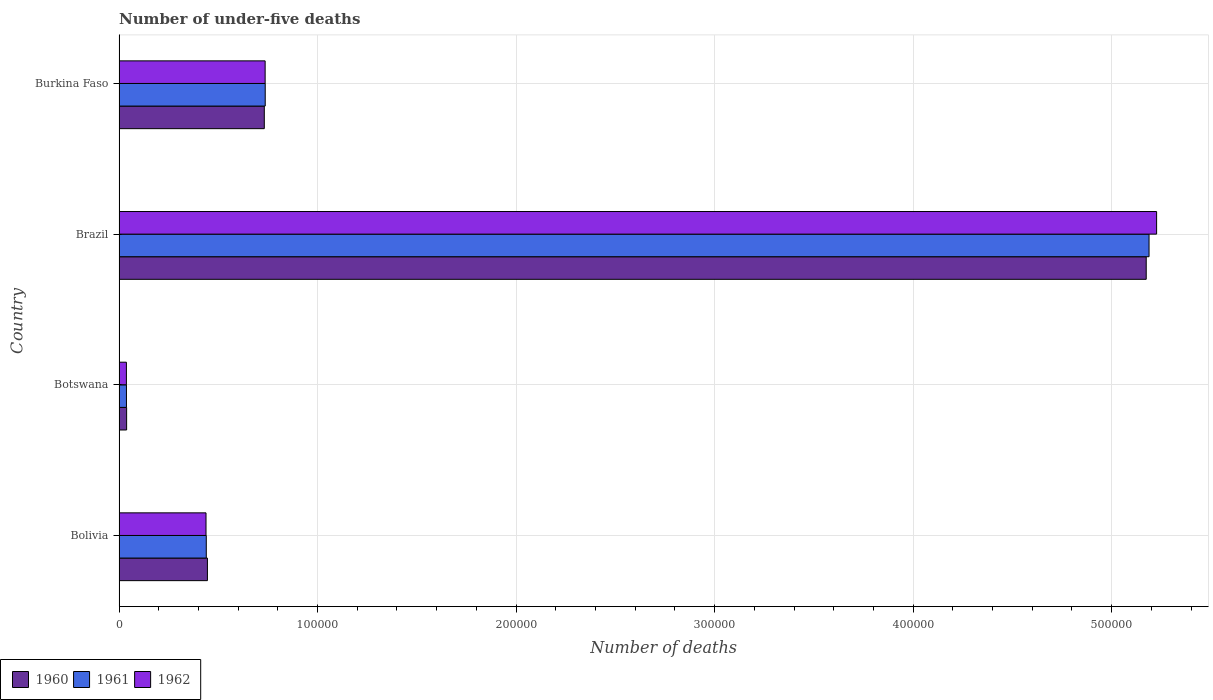How many different coloured bars are there?
Keep it short and to the point. 3. How many groups of bars are there?
Give a very brief answer. 4. How many bars are there on the 3rd tick from the bottom?
Provide a short and direct response. 3. What is the label of the 3rd group of bars from the top?
Provide a short and direct response. Botswana. In how many cases, is the number of bars for a given country not equal to the number of legend labels?
Provide a short and direct response. 0. What is the number of under-five deaths in 1961 in Botswana?
Your answer should be compact. 3727. Across all countries, what is the maximum number of under-five deaths in 1962?
Make the answer very short. 5.23e+05. Across all countries, what is the minimum number of under-five deaths in 1961?
Make the answer very short. 3727. In which country was the number of under-five deaths in 1961 maximum?
Ensure brevity in your answer.  Brazil. In which country was the number of under-five deaths in 1962 minimum?
Make the answer very short. Botswana. What is the total number of under-five deaths in 1960 in the graph?
Provide a short and direct response. 6.39e+05. What is the difference between the number of under-five deaths in 1960 in Bolivia and that in Burkina Faso?
Offer a very short reply. -2.87e+04. What is the difference between the number of under-five deaths in 1962 in Burkina Faso and the number of under-five deaths in 1961 in Botswana?
Offer a terse response. 6.99e+04. What is the average number of under-five deaths in 1960 per country?
Make the answer very short. 1.60e+05. What is the difference between the number of under-five deaths in 1961 and number of under-five deaths in 1962 in Burkina Faso?
Offer a very short reply. 42. What is the ratio of the number of under-five deaths in 1960 in Brazil to that in Burkina Faso?
Give a very brief answer. 7.07. What is the difference between the highest and the second highest number of under-five deaths in 1960?
Your answer should be very brief. 4.44e+05. What is the difference between the highest and the lowest number of under-five deaths in 1961?
Your answer should be compact. 5.15e+05. How many countries are there in the graph?
Your response must be concise. 4. Does the graph contain any zero values?
Your response must be concise. No. Where does the legend appear in the graph?
Keep it short and to the point. Bottom left. What is the title of the graph?
Keep it short and to the point. Number of under-five deaths. What is the label or title of the X-axis?
Provide a short and direct response. Number of deaths. What is the label or title of the Y-axis?
Your response must be concise. Country. What is the Number of deaths of 1960 in Bolivia?
Your answer should be very brief. 4.45e+04. What is the Number of deaths of 1961 in Bolivia?
Offer a terse response. 4.39e+04. What is the Number of deaths in 1962 in Bolivia?
Provide a short and direct response. 4.38e+04. What is the Number of deaths of 1960 in Botswana?
Your answer should be very brief. 3811. What is the Number of deaths of 1961 in Botswana?
Keep it short and to the point. 3727. What is the Number of deaths of 1962 in Botswana?
Ensure brevity in your answer.  3708. What is the Number of deaths in 1960 in Brazil?
Your answer should be very brief. 5.17e+05. What is the Number of deaths of 1961 in Brazil?
Offer a terse response. 5.19e+05. What is the Number of deaths of 1962 in Brazil?
Keep it short and to the point. 5.23e+05. What is the Number of deaths in 1960 in Burkina Faso?
Make the answer very short. 7.32e+04. What is the Number of deaths of 1961 in Burkina Faso?
Your answer should be compact. 7.36e+04. What is the Number of deaths of 1962 in Burkina Faso?
Keep it short and to the point. 7.36e+04. Across all countries, what is the maximum Number of deaths in 1960?
Your response must be concise. 5.17e+05. Across all countries, what is the maximum Number of deaths of 1961?
Your answer should be very brief. 5.19e+05. Across all countries, what is the maximum Number of deaths of 1962?
Provide a short and direct response. 5.23e+05. Across all countries, what is the minimum Number of deaths of 1960?
Your response must be concise. 3811. Across all countries, what is the minimum Number of deaths of 1961?
Give a very brief answer. 3727. Across all countries, what is the minimum Number of deaths in 1962?
Keep it short and to the point. 3708. What is the total Number of deaths in 1960 in the graph?
Provide a short and direct response. 6.39e+05. What is the total Number of deaths of 1961 in the graph?
Offer a terse response. 6.40e+05. What is the total Number of deaths in 1962 in the graph?
Your response must be concise. 6.44e+05. What is the difference between the Number of deaths of 1960 in Bolivia and that in Botswana?
Make the answer very short. 4.07e+04. What is the difference between the Number of deaths of 1961 in Bolivia and that in Botswana?
Give a very brief answer. 4.02e+04. What is the difference between the Number of deaths in 1962 in Bolivia and that in Botswana?
Provide a succinct answer. 4.01e+04. What is the difference between the Number of deaths of 1960 in Bolivia and that in Brazil?
Offer a very short reply. -4.73e+05. What is the difference between the Number of deaths of 1961 in Bolivia and that in Brazil?
Your response must be concise. -4.75e+05. What is the difference between the Number of deaths in 1962 in Bolivia and that in Brazil?
Provide a succinct answer. -4.79e+05. What is the difference between the Number of deaths in 1960 in Bolivia and that in Burkina Faso?
Provide a succinct answer. -2.87e+04. What is the difference between the Number of deaths of 1961 in Bolivia and that in Burkina Faso?
Keep it short and to the point. -2.97e+04. What is the difference between the Number of deaths of 1962 in Bolivia and that in Burkina Faso?
Provide a short and direct response. -2.98e+04. What is the difference between the Number of deaths in 1960 in Botswana and that in Brazil?
Provide a short and direct response. -5.14e+05. What is the difference between the Number of deaths of 1961 in Botswana and that in Brazil?
Make the answer very short. -5.15e+05. What is the difference between the Number of deaths of 1962 in Botswana and that in Brazil?
Give a very brief answer. -5.19e+05. What is the difference between the Number of deaths of 1960 in Botswana and that in Burkina Faso?
Your answer should be compact. -6.94e+04. What is the difference between the Number of deaths in 1961 in Botswana and that in Burkina Faso?
Offer a terse response. -6.99e+04. What is the difference between the Number of deaths of 1962 in Botswana and that in Burkina Faso?
Your answer should be very brief. -6.99e+04. What is the difference between the Number of deaths of 1960 in Brazil and that in Burkina Faso?
Offer a very short reply. 4.44e+05. What is the difference between the Number of deaths in 1961 in Brazil and that in Burkina Faso?
Offer a very short reply. 4.45e+05. What is the difference between the Number of deaths in 1962 in Brazil and that in Burkina Faso?
Keep it short and to the point. 4.49e+05. What is the difference between the Number of deaths in 1960 in Bolivia and the Number of deaths in 1961 in Botswana?
Offer a terse response. 4.08e+04. What is the difference between the Number of deaths in 1960 in Bolivia and the Number of deaths in 1962 in Botswana?
Your answer should be compact. 4.08e+04. What is the difference between the Number of deaths in 1961 in Bolivia and the Number of deaths in 1962 in Botswana?
Offer a terse response. 4.02e+04. What is the difference between the Number of deaths in 1960 in Bolivia and the Number of deaths in 1961 in Brazil?
Give a very brief answer. -4.74e+05. What is the difference between the Number of deaths in 1960 in Bolivia and the Number of deaths in 1962 in Brazil?
Provide a short and direct response. -4.78e+05. What is the difference between the Number of deaths in 1961 in Bolivia and the Number of deaths in 1962 in Brazil?
Offer a terse response. -4.79e+05. What is the difference between the Number of deaths of 1960 in Bolivia and the Number of deaths of 1961 in Burkina Faso?
Give a very brief answer. -2.91e+04. What is the difference between the Number of deaths of 1960 in Bolivia and the Number of deaths of 1962 in Burkina Faso?
Your answer should be very brief. -2.91e+04. What is the difference between the Number of deaths of 1961 in Bolivia and the Number of deaths of 1962 in Burkina Faso?
Make the answer very short. -2.96e+04. What is the difference between the Number of deaths of 1960 in Botswana and the Number of deaths of 1961 in Brazil?
Make the answer very short. -5.15e+05. What is the difference between the Number of deaths of 1960 in Botswana and the Number of deaths of 1962 in Brazil?
Your answer should be very brief. -5.19e+05. What is the difference between the Number of deaths in 1961 in Botswana and the Number of deaths in 1962 in Brazil?
Offer a very short reply. -5.19e+05. What is the difference between the Number of deaths of 1960 in Botswana and the Number of deaths of 1961 in Burkina Faso?
Ensure brevity in your answer.  -6.98e+04. What is the difference between the Number of deaths of 1960 in Botswana and the Number of deaths of 1962 in Burkina Faso?
Ensure brevity in your answer.  -6.98e+04. What is the difference between the Number of deaths of 1961 in Botswana and the Number of deaths of 1962 in Burkina Faso?
Offer a terse response. -6.99e+04. What is the difference between the Number of deaths of 1960 in Brazil and the Number of deaths of 1961 in Burkina Faso?
Give a very brief answer. 4.44e+05. What is the difference between the Number of deaths in 1960 in Brazil and the Number of deaths in 1962 in Burkina Faso?
Offer a terse response. 4.44e+05. What is the difference between the Number of deaths of 1961 in Brazil and the Number of deaths of 1962 in Burkina Faso?
Provide a succinct answer. 4.45e+05. What is the average Number of deaths of 1960 per country?
Make the answer very short. 1.60e+05. What is the average Number of deaths of 1961 per country?
Keep it short and to the point. 1.60e+05. What is the average Number of deaths of 1962 per country?
Your response must be concise. 1.61e+05. What is the difference between the Number of deaths in 1960 and Number of deaths in 1961 in Bolivia?
Your answer should be very brief. 571. What is the difference between the Number of deaths of 1960 and Number of deaths of 1962 in Bolivia?
Your response must be concise. 704. What is the difference between the Number of deaths of 1961 and Number of deaths of 1962 in Bolivia?
Offer a very short reply. 133. What is the difference between the Number of deaths of 1960 and Number of deaths of 1962 in Botswana?
Offer a terse response. 103. What is the difference between the Number of deaths in 1961 and Number of deaths in 1962 in Botswana?
Make the answer very short. 19. What is the difference between the Number of deaths of 1960 and Number of deaths of 1961 in Brazil?
Give a very brief answer. -1424. What is the difference between the Number of deaths of 1960 and Number of deaths of 1962 in Brazil?
Provide a succinct answer. -5233. What is the difference between the Number of deaths of 1961 and Number of deaths of 1962 in Brazil?
Offer a terse response. -3809. What is the difference between the Number of deaths in 1960 and Number of deaths in 1961 in Burkina Faso?
Provide a succinct answer. -465. What is the difference between the Number of deaths of 1960 and Number of deaths of 1962 in Burkina Faso?
Your answer should be compact. -423. What is the ratio of the Number of deaths in 1960 in Bolivia to that in Botswana?
Offer a terse response. 11.68. What is the ratio of the Number of deaths of 1961 in Bolivia to that in Botswana?
Make the answer very short. 11.79. What is the ratio of the Number of deaths of 1962 in Bolivia to that in Botswana?
Offer a terse response. 11.81. What is the ratio of the Number of deaths in 1960 in Bolivia to that in Brazil?
Your answer should be very brief. 0.09. What is the ratio of the Number of deaths in 1961 in Bolivia to that in Brazil?
Your answer should be compact. 0.08. What is the ratio of the Number of deaths in 1962 in Bolivia to that in Brazil?
Give a very brief answer. 0.08. What is the ratio of the Number of deaths of 1960 in Bolivia to that in Burkina Faso?
Your response must be concise. 0.61. What is the ratio of the Number of deaths in 1961 in Bolivia to that in Burkina Faso?
Offer a very short reply. 0.6. What is the ratio of the Number of deaths of 1962 in Bolivia to that in Burkina Faso?
Provide a short and direct response. 0.6. What is the ratio of the Number of deaths of 1960 in Botswana to that in Brazil?
Provide a succinct answer. 0.01. What is the ratio of the Number of deaths of 1961 in Botswana to that in Brazil?
Your answer should be very brief. 0.01. What is the ratio of the Number of deaths of 1962 in Botswana to that in Brazil?
Ensure brevity in your answer.  0.01. What is the ratio of the Number of deaths of 1960 in Botswana to that in Burkina Faso?
Your answer should be very brief. 0.05. What is the ratio of the Number of deaths in 1961 in Botswana to that in Burkina Faso?
Your response must be concise. 0.05. What is the ratio of the Number of deaths of 1962 in Botswana to that in Burkina Faso?
Provide a succinct answer. 0.05. What is the ratio of the Number of deaths in 1960 in Brazil to that in Burkina Faso?
Keep it short and to the point. 7.07. What is the ratio of the Number of deaths of 1961 in Brazil to that in Burkina Faso?
Provide a short and direct response. 7.05. What is the ratio of the Number of deaths of 1962 in Brazil to that in Burkina Faso?
Your answer should be very brief. 7.1. What is the difference between the highest and the second highest Number of deaths in 1960?
Make the answer very short. 4.44e+05. What is the difference between the highest and the second highest Number of deaths of 1961?
Offer a terse response. 4.45e+05. What is the difference between the highest and the second highest Number of deaths of 1962?
Your answer should be compact. 4.49e+05. What is the difference between the highest and the lowest Number of deaths in 1960?
Your response must be concise. 5.14e+05. What is the difference between the highest and the lowest Number of deaths in 1961?
Ensure brevity in your answer.  5.15e+05. What is the difference between the highest and the lowest Number of deaths in 1962?
Offer a very short reply. 5.19e+05. 